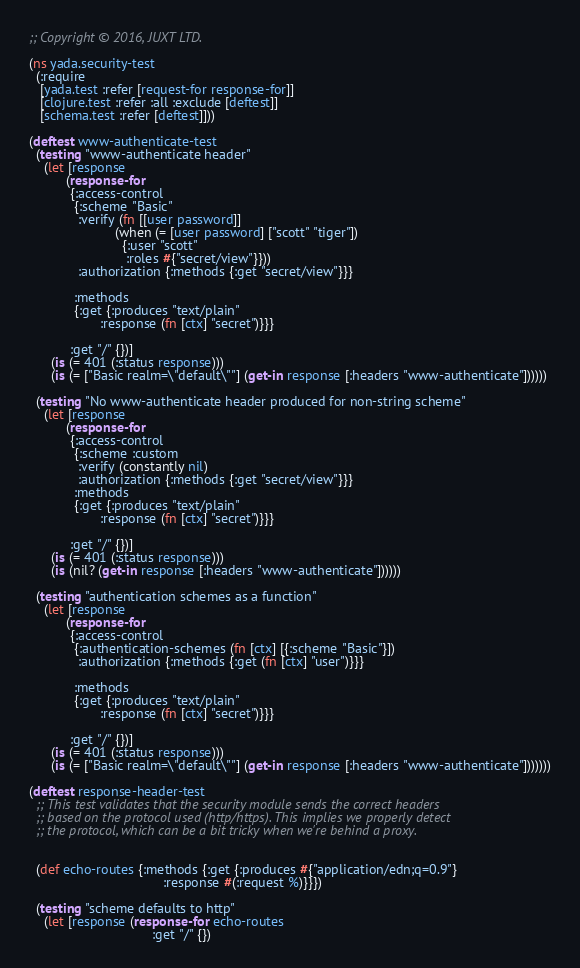Convert code to text. <code><loc_0><loc_0><loc_500><loc_500><_Clojure_>;; Copyright © 2016, JUXT LTD.

(ns yada.security-test
  (:require
   [yada.test :refer [request-for response-for]]
   [clojure.test :refer :all :exclude [deftest]]
   [schema.test :refer [deftest]]))

(deftest www-authenticate-test
  (testing "www-authenticate header"
    (let [response
          (response-for
           {:access-control
            {:scheme "Basic"
             :verify (fn [[user password]]
                       (when (= [user password] ["scott" "tiger"])
                         {:user "scott"
                          :roles #{"secret/view"}}))
             :authorization {:methods {:get "secret/view"}}}

            :methods
            {:get {:produces "text/plain"
                   :response (fn [ctx] "secret")}}}

           :get "/" {})]
      (is (= 401 (:status response)))
      (is (= ["Basic realm=\"default\""] (get-in response [:headers "www-authenticate"])))))

  (testing "No www-authenticate header produced for non-string scheme"
    (let [response
          (response-for
           {:access-control
            {:scheme :custom
             :verify (constantly nil)
             :authorization {:methods {:get "secret/view"}}}
            :methods
            {:get {:produces "text/plain"
                   :response (fn [ctx] "secret")}}}

           :get "/" {})]
      (is (= 401 (:status response)))
      (is (nil? (get-in response [:headers "www-authenticate"])))))

  (testing "authentication schemes as a function"
    (let [response
          (response-for
           {:access-control
            {:authentication-schemes (fn [ctx] [{:scheme "Basic"}])
             :authorization {:methods {:get (fn [ctx] "user")}}}

            :methods
            {:get {:produces "text/plain"
                   :response (fn [ctx] "secret")}}}

           :get "/" {})]
      (is (= 401 (:status response)))
      (is (= ["Basic realm=\"default\""] (get-in response [:headers "www-authenticate"]))))))

(deftest response-header-test
  ;; This test validates that the security module sends the correct headers
  ;; based on the protocol used (http/https). This implies we properly detect
  ;; the protocol, which can be a bit tricky when we're behind a proxy.


  (def echo-routes {:methods {:get {:produces #{"application/edn;q=0.9"}
                                    :response #(:request %)}}})

  (testing "scheme defaults to http"
    (let [response (response-for echo-routes
                                 :get "/" {})</code> 